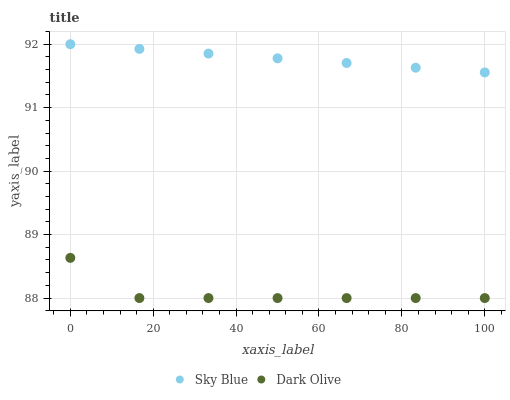Does Dark Olive have the minimum area under the curve?
Answer yes or no. Yes. Does Sky Blue have the maximum area under the curve?
Answer yes or no. Yes. Does Dark Olive have the maximum area under the curve?
Answer yes or no. No. Is Sky Blue the smoothest?
Answer yes or no. Yes. Is Dark Olive the roughest?
Answer yes or no. Yes. Is Dark Olive the smoothest?
Answer yes or no. No. Does Dark Olive have the lowest value?
Answer yes or no. Yes. Does Sky Blue have the highest value?
Answer yes or no. Yes. Does Dark Olive have the highest value?
Answer yes or no. No. Is Dark Olive less than Sky Blue?
Answer yes or no. Yes. Is Sky Blue greater than Dark Olive?
Answer yes or no. Yes. Does Dark Olive intersect Sky Blue?
Answer yes or no. No. 